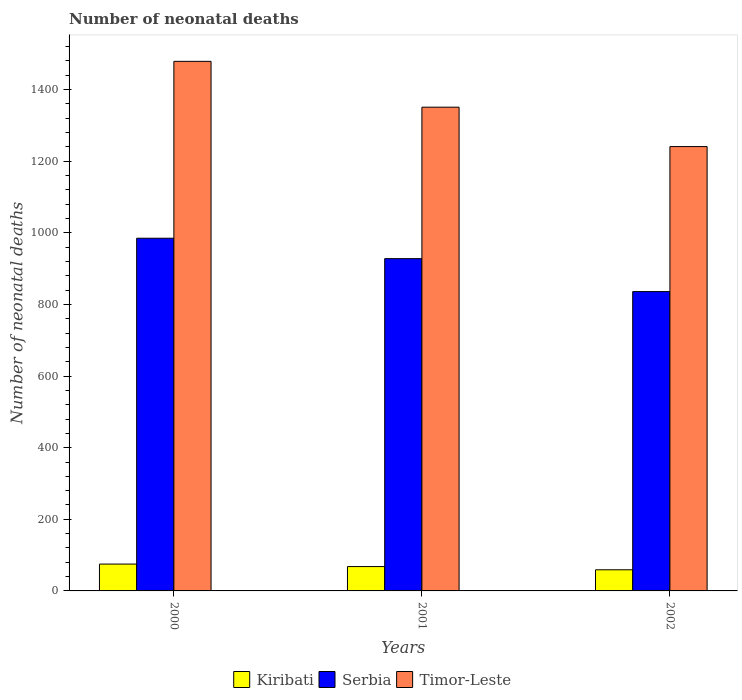How many different coloured bars are there?
Give a very brief answer. 3. How many groups of bars are there?
Offer a terse response. 3. Are the number of bars per tick equal to the number of legend labels?
Make the answer very short. Yes. How many bars are there on the 3rd tick from the left?
Offer a very short reply. 3. What is the number of neonatal deaths in in Kiribati in 2000?
Offer a very short reply. 75. Across all years, what is the maximum number of neonatal deaths in in Kiribati?
Give a very brief answer. 75. Across all years, what is the minimum number of neonatal deaths in in Serbia?
Make the answer very short. 836. In which year was the number of neonatal deaths in in Kiribati maximum?
Offer a very short reply. 2000. What is the total number of neonatal deaths in in Timor-Leste in the graph?
Provide a succinct answer. 4071. What is the difference between the number of neonatal deaths in in Kiribati in 2000 and that in 2002?
Ensure brevity in your answer.  16. What is the difference between the number of neonatal deaths in in Timor-Leste in 2000 and the number of neonatal deaths in in Serbia in 2002?
Your response must be concise. 643. What is the average number of neonatal deaths in in Timor-Leste per year?
Your response must be concise. 1357. In the year 2000, what is the difference between the number of neonatal deaths in in Kiribati and number of neonatal deaths in in Serbia?
Ensure brevity in your answer.  -910. In how many years, is the number of neonatal deaths in in Serbia greater than 1080?
Your response must be concise. 0. What is the ratio of the number of neonatal deaths in in Kiribati in 2001 to that in 2002?
Give a very brief answer. 1.15. Is the number of neonatal deaths in in Serbia in 2000 less than that in 2001?
Provide a short and direct response. No. Is the difference between the number of neonatal deaths in in Kiribati in 2000 and 2001 greater than the difference between the number of neonatal deaths in in Serbia in 2000 and 2001?
Provide a short and direct response. No. What is the difference between the highest and the second highest number of neonatal deaths in in Timor-Leste?
Ensure brevity in your answer.  128. What is the difference between the highest and the lowest number of neonatal deaths in in Serbia?
Make the answer very short. 149. In how many years, is the number of neonatal deaths in in Timor-Leste greater than the average number of neonatal deaths in in Timor-Leste taken over all years?
Your response must be concise. 1. Is the sum of the number of neonatal deaths in in Serbia in 2000 and 2001 greater than the maximum number of neonatal deaths in in Kiribati across all years?
Keep it short and to the point. Yes. What does the 1st bar from the left in 2001 represents?
Ensure brevity in your answer.  Kiribati. What does the 3rd bar from the right in 2001 represents?
Ensure brevity in your answer.  Kiribati. Are all the bars in the graph horizontal?
Offer a terse response. No. What is the difference between two consecutive major ticks on the Y-axis?
Your answer should be compact. 200. Are the values on the major ticks of Y-axis written in scientific E-notation?
Offer a terse response. No. Does the graph contain grids?
Ensure brevity in your answer.  No. Where does the legend appear in the graph?
Offer a terse response. Bottom center. How are the legend labels stacked?
Provide a succinct answer. Horizontal. What is the title of the graph?
Your response must be concise. Number of neonatal deaths. What is the label or title of the X-axis?
Give a very brief answer. Years. What is the label or title of the Y-axis?
Offer a terse response. Number of neonatal deaths. What is the Number of neonatal deaths of Kiribati in 2000?
Give a very brief answer. 75. What is the Number of neonatal deaths in Serbia in 2000?
Provide a short and direct response. 985. What is the Number of neonatal deaths in Timor-Leste in 2000?
Give a very brief answer. 1479. What is the Number of neonatal deaths of Kiribati in 2001?
Ensure brevity in your answer.  68. What is the Number of neonatal deaths of Serbia in 2001?
Your answer should be very brief. 928. What is the Number of neonatal deaths of Timor-Leste in 2001?
Provide a short and direct response. 1351. What is the Number of neonatal deaths in Serbia in 2002?
Your response must be concise. 836. What is the Number of neonatal deaths of Timor-Leste in 2002?
Your answer should be compact. 1241. Across all years, what is the maximum Number of neonatal deaths in Serbia?
Provide a succinct answer. 985. Across all years, what is the maximum Number of neonatal deaths in Timor-Leste?
Your response must be concise. 1479. Across all years, what is the minimum Number of neonatal deaths in Serbia?
Give a very brief answer. 836. Across all years, what is the minimum Number of neonatal deaths in Timor-Leste?
Make the answer very short. 1241. What is the total Number of neonatal deaths in Kiribati in the graph?
Give a very brief answer. 202. What is the total Number of neonatal deaths in Serbia in the graph?
Provide a short and direct response. 2749. What is the total Number of neonatal deaths of Timor-Leste in the graph?
Give a very brief answer. 4071. What is the difference between the Number of neonatal deaths of Kiribati in 2000 and that in 2001?
Make the answer very short. 7. What is the difference between the Number of neonatal deaths of Serbia in 2000 and that in 2001?
Make the answer very short. 57. What is the difference between the Number of neonatal deaths of Timor-Leste in 2000 and that in 2001?
Give a very brief answer. 128. What is the difference between the Number of neonatal deaths in Kiribati in 2000 and that in 2002?
Give a very brief answer. 16. What is the difference between the Number of neonatal deaths in Serbia in 2000 and that in 2002?
Your answer should be compact. 149. What is the difference between the Number of neonatal deaths in Timor-Leste in 2000 and that in 2002?
Keep it short and to the point. 238. What is the difference between the Number of neonatal deaths of Kiribati in 2001 and that in 2002?
Provide a succinct answer. 9. What is the difference between the Number of neonatal deaths in Serbia in 2001 and that in 2002?
Make the answer very short. 92. What is the difference between the Number of neonatal deaths in Timor-Leste in 2001 and that in 2002?
Your response must be concise. 110. What is the difference between the Number of neonatal deaths of Kiribati in 2000 and the Number of neonatal deaths of Serbia in 2001?
Offer a very short reply. -853. What is the difference between the Number of neonatal deaths of Kiribati in 2000 and the Number of neonatal deaths of Timor-Leste in 2001?
Your answer should be compact. -1276. What is the difference between the Number of neonatal deaths in Serbia in 2000 and the Number of neonatal deaths in Timor-Leste in 2001?
Keep it short and to the point. -366. What is the difference between the Number of neonatal deaths in Kiribati in 2000 and the Number of neonatal deaths in Serbia in 2002?
Offer a terse response. -761. What is the difference between the Number of neonatal deaths in Kiribati in 2000 and the Number of neonatal deaths in Timor-Leste in 2002?
Provide a short and direct response. -1166. What is the difference between the Number of neonatal deaths of Serbia in 2000 and the Number of neonatal deaths of Timor-Leste in 2002?
Your answer should be compact. -256. What is the difference between the Number of neonatal deaths of Kiribati in 2001 and the Number of neonatal deaths of Serbia in 2002?
Ensure brevity in your answer.  -768. What is the difference between the Number of neonatal deaths of Kiribati in 2001 and the Number of neonatal deaths of Timor-Leste in 2002?
Offer a terse response. -1173. What is the difference between the Number of neonatal deaths in Serbia in 2001 and the Number of neonatal deaths in Timor-Leste in 2002?
Your answer should be very brief. -313. What is the average Number of neonatal deaths in Kiribati per year?
Give a very brief answer. 67.33. What is the average Number of neonatal deaths in Serbia per year?
Keep it short and to the point. 916.33. What is the average Number of neonatal deaths of Timor-Leste per year?
Offer a very short reply. 1357. In the year 2000, what is the difference between the Number of neonatal deaths in Kiribati and Number of neonatal deaths in Serbia?
Keep it short and to the point. -910. In the year 2000, what is the difference between the Number of neonatal deaths of Kiribati and Number of neonatal deaths of Timor-Leste?
Your response must be concise. -1404. In the year 2000, what is the difference between the Number of neonatal deaths in Serbia and Number of neonatal deaths in Timor-Leste?
Make the answer very short. -494. In the year 2001, what is the difference between the Number of neonatal deaths in Kiribati and Number of neonatal deaths in Serbia?
Your response must be concise. -860. In the year 2001, what is the difference between the Number of neonatal deaths in Kiribati and Number of neonatal deaths in Timor-Leste?
Give a very brief answer. -1283. In the year 2001, what is the difference between the Number of neonatal deaths in Serbia and Number of neonatal deaths in Timor-Leste?
Make the answer very short. -423. In the year 2002, what is the difference between the Number of neonatal deaths in Kiribati and Number of neonatal deaths in Serbia?
Offer a terse response. -777. In the year 2002, what is the difference between the Number of neonatal deaths in Kiribati and Number of neonatal deaths in Timor-Leste?
Provide a succinct answer. -1182. In the year 2002, what is the difference between the Number of neonatal deaths of Serbia and Number of neonatal deaths of Timor-Leste?
Offer a very short reply. -405. What is the ratio of the Number of neonatal deaths in Kiribati in 2000 to that in 2001?
Your response must be concise. 1.1. What is the ratio of the Number of neonatal deaths in Serbia in 2000 to that in 2001?
Offer a very short reply. 1.06. What is the ratio of the Number of neonatal deaths of Timor-Leste in 2000 to that in 2001?
Your answer should be compact. 1.09. What is the ratio of the Number of neonatal deaths of Kiribati in 2000 to that in 2002?
Offer a very short reply. 1.27. What is the ratio of the Number of neonatal deaths in Serbia in 2000 to that in 2002?
Make the answer very short. 1.18. What is the ratio of the Number of neonatal deaths of Timor-Leste in 2000 to that in 2002?
Provide a succinct answer. 1.19. What is the ratio of the Number of neonatal deaths in Kiribati in 2001 to that in 2002?
Give a very brief answer. 1.15. What is the ratio of the Number of neonatal deaths of Serbia in 2001 to that in 2002?
Offer a terse response. 1.11. What is the ratio of the Number of neonatal deaths in Timor-Leste in 2001 to that in 2002?
Make the answer very short. 1.09. What is the difference between the highest and the second highest Number of neonatal deaths of Serbia?
Keep it short and to the point. 57. What is the difference between the highest and the second highest Number of neonatal deaths of Timor-Leste?
Provide a succinct answer. 128. What is the difference between the highest and the lowest Number of neonatal deaths in Kiribati?
Provide a succinct answer. 16. What is the difference between the highest and the lowest Number of neonatal deaths of Serbia?
Make the answer very short. 149. What is the difference between the highest and the lowest Number of neonatal deaths in Timor-Leste?
Make the answer very short. 238. 